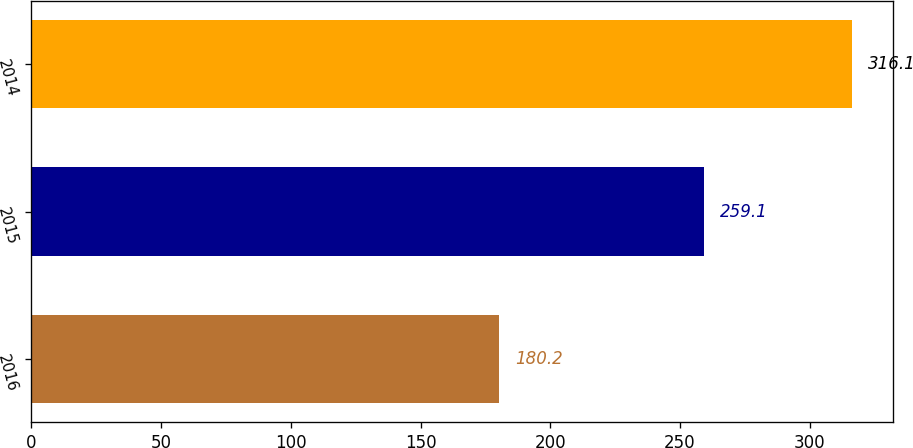<chart> <loc_0><loc_0><loc_500><loc_500><bar_chart><fcel>2016<fcel>2015<fcel>2014<nl><fcel>180.2<fcel>259.1<fcel>316.1<nl></chart> 